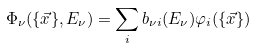<formula> <loc_0><loc_0><loc_500><loc_500>\Phi _ { \nu } ( \{ \vec { x } \} , E _ { \nu } ) = \sum _ { i } b _ { \nu i } ( E _ { \nu } ) \varphi _ { i } ( \{ \vec { x } \} )</formula> 